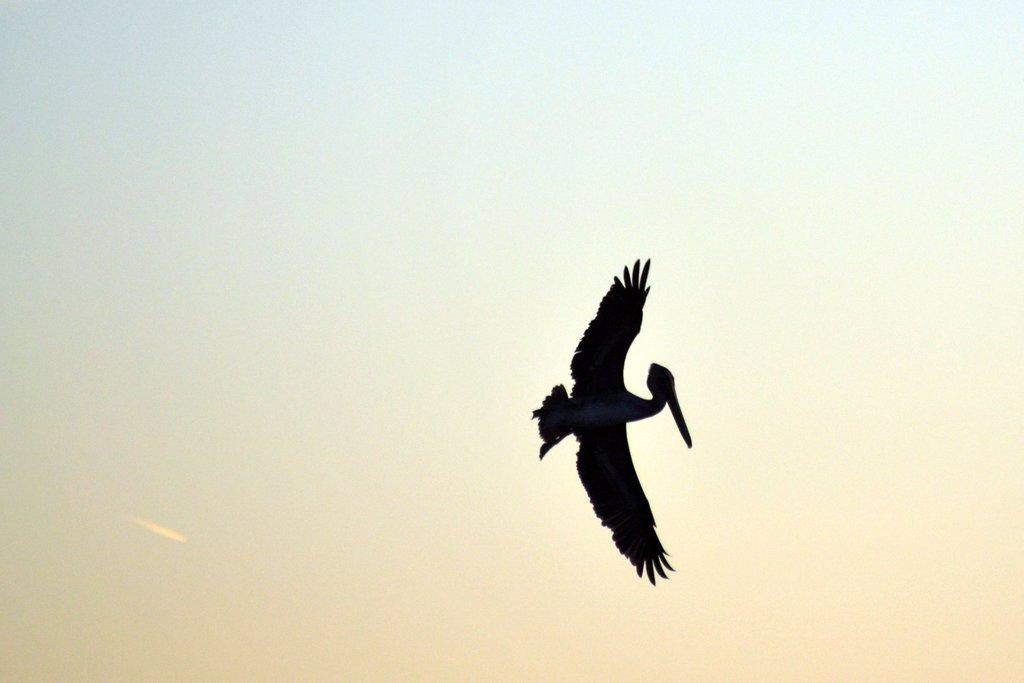What is the main subject of the image? The main subject of the image is a bird flying. What can be seen in the background of the image? The sky is visible in the background of the image. Can you see an island in the image? There is no island present in the image. Is there a sofa visible in the image? There is no sofa present in the image. 